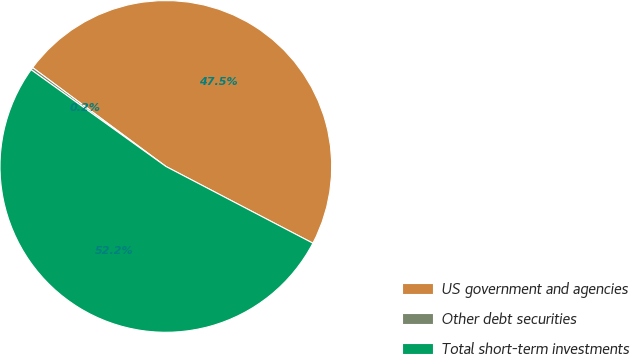Convert chart to OTSL. <chart><loc_0><loc_0><loc_500><loc_500><pie_chart><fcel>US government and agencies<fcel>Other debt securities<fcel>Total short-term investments<nl><fcel>47.5%<fcel>0.25%<fcel>52.25%<nl></chart> 